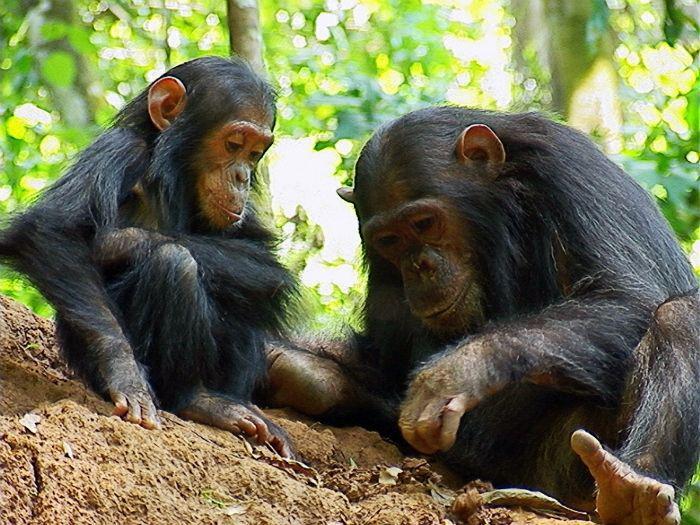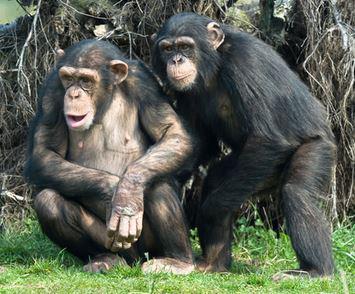The first image is the image on the left, the second image is the image on the right. Assess this claim about the two images: "One chimpanzee is touching another chimpanzee with both its hands.". Correct or not? Answer yes or no. No. The first image is the image on the left, the second image is the image on the right. Analyze the images presented: Is the assertion "There are four chimpanzees." valid? Answer yes or no. Yes. 